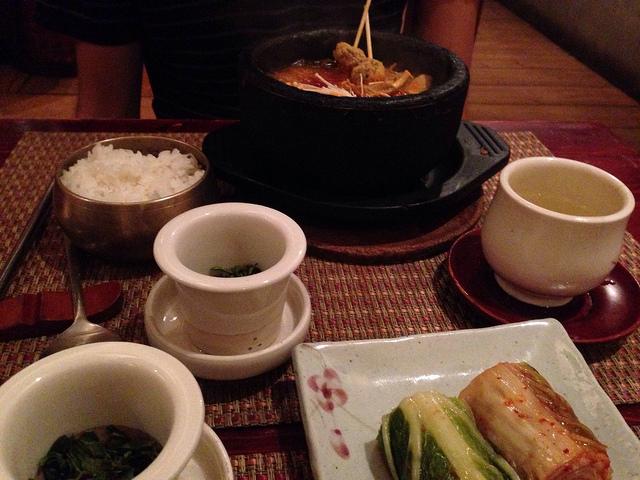What color is the right saucer?
Concise answer only. Red. Is there rice in the photo?
Keep it brief. Yes. What is in the black pot?
Be succinct. Soup. 